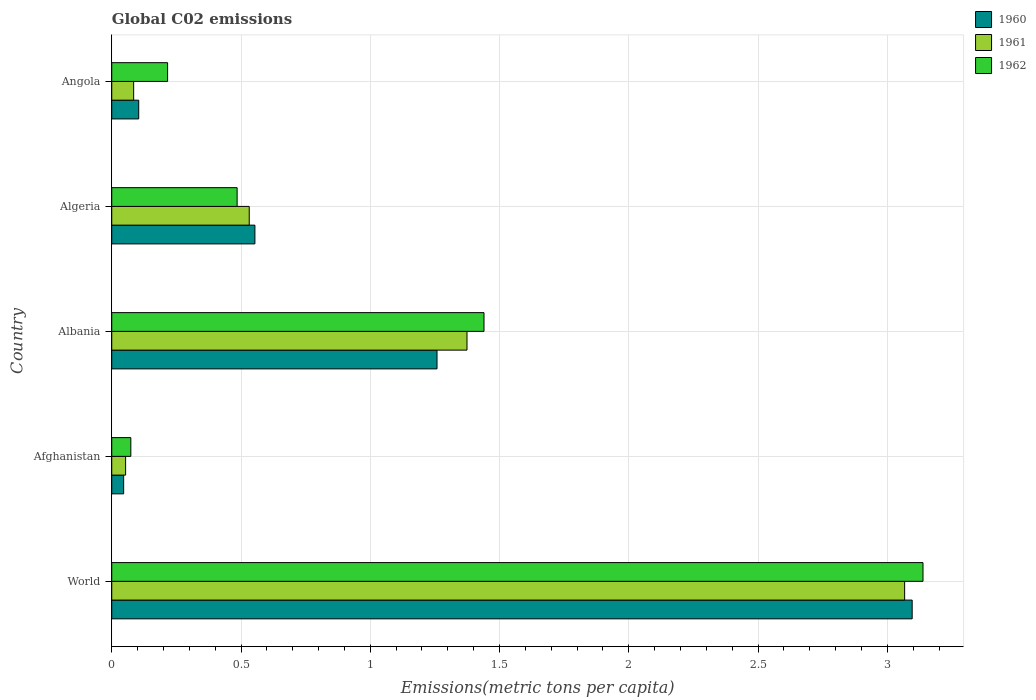How many different coloured bars are there?
Provide a short and direct response. 3. Are the number of bars per tick equal to the number of legend labels?
Provide a succinct answer. Yes. Are the number of bars on each tick of the Y-axis equal?
Keep it short and to the point. Yes. In how many cases, is the number of bars for a given country not equal to the number of legend labels?
Your answer should be compact. 0. What is the amount of CO2 emitted in in 1961 in Algeria?
Your answer should be compact. 0.53. Across all countries, what is the maximum amount of CO2 emitted in in 1961?
Offer a very short reply. 3.07. Across all countries, what is the minimum amount of CO2 emitted in in 1962?
Provide a short and direct response. 0.07. In which country was the amount of CO2 emitted in in 1961 maximum?
Your response must be concise. World. In which country was the amount of CO2 emitted in in 1962 minimum?
Provide a succinct answer. Afghanistan. What is the total amount of CO2 emitted in in 1961 in the graph?
Provide a succinct answer. 5.11. What is the difference between the amount of CO2 emitted in in 1960 in Albania and that in Angola?
Your answer should be compact. 1.15. What is the difference between the amount of CO2 emitted in in 1961 in World and the amount of CO2 emitted in in 1962 in Angola?
Provide a succinct answer. 2.85. What is the average amount of CO2 emitted in in 1961 per country?
Provide a succinct answer. 1.02. What is the difference between the amount of CO2 emitted in in 1960 and amount of CO2 emitted in in 1961 in Angola?
Ensure brevity in your answer.  0.02. In how many countries, is the amount of CO2 emitted in in 1960 greater than 2.9 metric tons per capita?
Offer a very short reply. 1. What is the ratio of the amount of CO2 emitted in in 1962 in Afghanistan to that in Angola?
Your answer should be compact. 0.34. Is the amount of CO2 emitted in in 1961 in Albania less than that in World?
Your answer should be compact. Yes. What is the difference between the highest and the second highest amount of CO2 emitted in in 1960?
Ensure brevity in your answer.  1.84. What is the difference between the highest and the lowest amount of CO2 emitted in in 1962?
Make the answer very short. 3.06. What does the 2nd bar from the top in Albania represents?
Offer a very short reply. 1961. What does the 3rd bar from the bottom in World represents?
Give a very brief answer. 1962. Is it the case that in every country, the sum of the amount of CO2 emitted in in 1962 and amount of CO2 emitted in in 1960 is greater than the amount of CO2 emitted in in 1961?
Keep it short and to the point. Yes. What is the difference between two consecutive major ticks on the X-axis?
Your answer should be very brief. 0.5. Does the graph contain grids?
Ensure brevity in your answer.  Yes. How are the legend labels stacked?
Your response must be concise. Vertical. What is the title of the graph?
Provide a succinct answer. Global C02 emissions. Does "1971" appear as one of the legend labels in the graph?
Give a very brief answer. No. What is the label or title of the X-axis?
Your answer should be compact. Emissions(metric tons per capita). What is the label or title of the Y-axis?
Provide a succinct answer. Country. What is the Emissions(metric tons per capita) in 1960 in World?
Provide a short and direct response. 3.1. What is the Emissions(metric tons per capita) of 1961 in World?
Provide a short and direct response. 3.07. What is the Emissions(metric tons per capita) in 1962 in World?
Your response must be concise. 3.14. What is the Emissions(metric tons per capita) of 1960 in Afghanistan?
Make the answer very short. 0.05. What is the Emissions(metric tons per capita) of 1961 in Afghanistan?
Make the answer very short. 0.05. What is the Emissions(metric tons per capita) in 1962 in Afghanistan?
Your response must be concise. 0.07. What is the Emissions(metric tons per capita) of 1960 in Albania?
Offer a very short reply. 1.26. What is the Emissions(metric tons per capita) of 1961 in Albania?
Your answer should be compact. 1.37. What is the Emissions(metric tons per capita) of 1962 in Albania?
Give a very brief answer. 1.44. What is the Emissions(metric tons per capita) of 1960 in Algeria?
Offer a very short reply. 0.55. What is the Emissions(metric tons per capita) of 1961 in Algeria?
Give a very brief answer. 0.53. What is the Emissions(metric tons per capita) of 1962 in Algeria?
Provide a short and direct response. 0.48. What is the Emissions(metric tons per capita) of 1960 in Angola?
Keep it short and to the point. 0.1. What is the Emissions(metric tons per capita) in 1961 in Angola?
Offer a very short reply. 0.08. What is the Emissions(metric tons per capita) of 1962 in Angola?
Offer a terse response. 0.22. Across all countries, what is the maximum Emissions(metric tons per capita) in 1960?
Ensure brevity in your answer.  3.1. Across all countries, what is the maximum Emissions(metric tons per capita) of 1961?
Your response must be concise. 3.07. Across all countries, what is the maximum Emissions(metric tons per capita) of 1962?
Give a very brief answer. 3.14. Across all countries, what is the minimum Emissions(metric tons per capita) in 1960?
Provide a succinct answer. 0.05. Across all countries, what is the minimum Emissions(metric tons per capita) of 1961?
Give a very brief answer. 0.05. Across all countries, what is the minimum Emissions(metric tons per capita) in 1962?
Make the answer very short. 0.07. What is the total Emissions(metric tons per capita) of 1960 in the graph?
Keep it short and to the point. 5.06. What is the total Emissions(metric tons per capita) of 1961 in the graph?
Your response must be concise. 5.11. What is the total Emissions(metric tons per capita) in 1962 in the graph?
Offer a terse response. 5.35. What is the difference between the Emissions(metric tons per capita) of 1960 in World and that in Afghanistan?
Provide a short and direct response. 3.05. What is the difference between the Emissions(metric tons per capita) of 1961 in World and that in Afghanistan?
Offer a terse response. 3.01. What is the difference between the Emissions(metric tons per capita) in 1962 in World and that in Afghanistan?
Offer a very short reply. 3.06. What is the difference between the Emissions(metric tons per capita) in 1960 in World and that in Albania?
Offer a very short reply. 1.84. What is the difference between the Emissions(metric tons per capita) of 1961 in World and that in Albania?
Offer a terse response. 1.69. What is the difference between the Emissions(metric tons per capita) in 1962 in World and that in Albania?
Your answer should be compact. 1.7. What is the difference between the Emissions(metric tons per capita) of 1960 in World and that in Algeria?
Offer a very short reply. 2.54. What is the difference between the Emissions(metric tons per capita) in 1961 in World and that in Algeria?
Your answer should be compact. 2.54. What is the difference between the Emissions(metric tons per capita) in 1962 in World and that in Algeria?
Offer a very short reply. 2.65. What is the difference between the Emissions(metric tons per capita) in 1960 in World and that in Angola?
Your answer should be very brief. 2.99. What is the difference between the Emissions(metric tons per capita) in 1961 in World and that in Angola?
Offer a very short reply. 2.98. What is the difference between the Emissions(metric tons per capita) in 1962 in World and that in Angola?
Ensure brevity in your answer.  2.92. What is the difference between the Emissions(metric tons per capita) of 1960 in Afghanistan and that in Albania?
Provide a succinct answer. -1.21. What is the difference between the Emissions(metric tons per capita) of 1961 in Afghanistan and that in Albania?
Offer a very short reply. -1.32. What is the difference between the Emissions(metric tons per capita) of 1962 in Afghanistan and that in Albania?
Your answer should be very brief. -1.37. What is the difference between the Emissions(metric tons per capita) of 1960 in Afghanistan and that in Algeria?
Offer a very short reply. -0.51. What is the difference between the Emissions(metric tons per capita) in 1961 in Afghanistan and that in Algeria?
Provide a short and direct response. -0.48. What is the difference between the Emissions(metric tons per capita) of 1962 in Afghanistan and that in Algeria?
Provide a succinct answer. -0.41. What is the difference between the Emissions(metric tons per capita) in 1960 in Afghanistan and that in Angola?
Offer a very short reply. -0.06. What is the difference between the Emissions(metric tons per capita) of 1961 in Afghanistan and that in Angola?
Your answer should be compact. -0.03. What is the difference between the Emissions(metric tons per capita) of 1962 in Afghanistan and that in Angola?
Offer a terse response. -0.14. What is the difference between the Emissions(metric tons per capita) in 1960 in Albania and that in Algeria?
Provide a succinct answer. 0.7. What is the difference between the Emissions(metric tons per capita) of 1961 in Albania and that in Algeria?
Offer a very short reply. 0.84. What is the difference between the Emissions(metric tons per capita) in 1962 in Albania and that in Algeria?
Give a very brief answer. 0.95. What is the difference between the Emissions(metric tons per capita) in 1960 in Albania and that in Angola?
Give a very brief answer. 1.15. What is the difference between the Emissions(metric tons per capita) of 1961 in Albania and that in Angola?
Your answer should be very brief. 1.29. What is the difference between the Emissions(metric tons per capita) of 1962 in Albania and that in Angola?
Provide a succinct answer. 1.22. What is the difference between the Emissions(metric tons per capita) in 1960 in Algeria and that in Angola?
Your answer should be compact. 0.45. What is the difference between the Emissions(metric tons per capita) of 1961 in Algeria and that in Angola?
Your answer should be compact. 0.45. What is the difference between the Emissions(metric tons per capita) of 1962 in Algeria and that in Angola?
Keep it short and to the point. 0.27. What is the difference between the Emissions(metric tons per capita) of 1960 in World and the Emissions(metric tons per capita) of 1961 in Afghanistan?
Your answer should be very brief. 3.04. What is the difference between the Emissions(metric tons per capita) in 1960 in World and the Emissions(metric tons per capita) in 1962 in Afghanistan?
Provide a short and direct response. 3.02. What is the difference between the Emissions(metric tons per capita) in 1961 in World and the Emissions(metric tons per capita) in 1962 in Afghanistan?
Your answer should be very brief. 2.99. What is the difference between the Emissions(metric tons per capita) of 1960 in World and the Emissions(metric tons per capita) of 1961 in Albania?
Your answer should be very brief. 1.72. What is the difference between the Emissions(metric tons per capita) in 1960 in World and the Emissions(metric tons per capita) in 1962 in Albania?
Give a very brief answer. 1.66. What is the difference between the Emissions(metric tons per capita) of 1961 in World and the Emissions(metric tons per capita) of 1962 in Albania?
Keep it short and to the point. 1.63. What is the difference between the Emissions(metric tons per capita) of 1960 in World and the Emissions(metric tons per capita) of 1961 in Algeria?
Your answer should be very brief. 2.56. What is the difference between the Emissions(metric tons per capita) of 1960 in World and the Emissions(metric tons per capita) of 1962 in Algeria?
Your answer should be very brief. 2.61. What is the difference between the Emissions(metric tons per capita) of 1961 in World and the Emissions(metric tons per capita) of 1962 in Algeria?
Offer a very short reply. 2.58. What is the difference between the Emissions(metric tons per capita) in 1960 in World and the Emissions(metric tons per capita) in 1961 in Angola?
Your answer should be very brief. 3.01. What is the difference between the Emissions(metric tons per capita) of 1960 in World and the Emissions(metric tons per capita) of 1962 in Angola?
Ensure brevity in your answer.  2.88. What is the difference between the Emissions(metric tons per capita) of 1961 in World and the Emissions(metric tons per capita) of 1962 in Angola?
Offer a terse response. 2.85. What is the difference between the Emissions(metric tons per capita) of 1960 in Afghanistan and the Emissions(metric tons per capita) of 1961 in Albania?
Offer a terse response. -1.33. What is the difference between the Emissions(metric tons per capita) in 1960 in Afghanistan and the Emissions(metric tons per capita) in 1962 in Albania?
Your answer should be very brief. -1.39. What is the difference between the Emissions(metric tons per capita) in 1961 in Afghanistan and the Emissions(metric tons per capita) in 1962 in Albania?
Your answer should be very brief. -1.39. What is the difference between the Emissions(metric tons per capita) of 1960 in Afghanistan and the Emissions(metric tons per capita) of 1961 in Algeria?
Ensure brevity in your answer.  -0.49. What is the difference between the Emissions(metric tons per capita) of 1960 in Afghanistan and the Emissions(metric tons per capita) of 1962 in Algeria?
Make the answer very short. -0.44. What is the difference between the Emissions(metric tons per capita) of 1961 in Afghanistan and the Emissions(metric tons per capita) of 1962 in Algeria?
Make the answer very short. -0.43. What is the difference between the Emissions(metric tons per capita) in 1960 in Afghanistan and the Emissions(metric tons per capita) in 1961 in Angola?
Your answer should be compact. -0.04. What is the difference between the Emissions(metric tons per capita) in 1960 in Afghanistan and the Emissions(metric tons per capita) in 1962 in Angola?
Make the answer very short. -0.17. What is the difference between the Emissions(metric tons per capita) in 1961 in Afghanistan and the Emissions(metric tons per capita) in 1962 in Angola?
Keep it short and to the point. -0.16. What is the difference between the Emissions(metric tons per capita) in 1960 in Albania and the Emissions(metric tons per capita) in 1961 in Algeria?
Provide a succinct answer. 0.73. What is the difference between the Emissions(metric tons per capita) of 1960 in Albania and the Emissions(metric tons per capita) of 1962 in Algeria?
Make the answer very short. 0.77. What is the difference between the Emissions(metric tons per capita) of 1961 in Albania and the Emissions(metric tons per capita) of 1962 in Algeria?
Offer a very short reply. 0.89. What is the difference between the Emissions(metric tons per capita) of 1960 in Albania and the Emissions(metric tons per capita) of 1961 in Angola?
Provide a succinct answer. 1.17. What is the difference between the Emissions(metric tons per capita) of 1960 in Albania and the Emissions(metric tons per capita) of 1962 in Angola?
Your answer should be very brief. 1.04. What is the difference between the Emissions(metric tons per capita) in 1961 in Albania and the Emissions(metric tons per capita) in 1962 in Angola?
Keep it short and to the point. 1.16. What is the difference between the Emissions(metric tons per capita) of 1960 in Algeria and the Emissions(metric tons per capita) of 1961 in Angola?
Provide a short and direct response. 0.47. What is the difference between the Emissions(metric tons per capita) in 1960 in Algeria and the Emissions(metric tons per capita) in 1962 in Angola?
Your answer should be very brief. 0.34. What is the difference between the Emissions(metric tons per capita) of 1961 in Algeria and the Emissions(metric tons per capita) of 1962 in Angola?
Offer a terse response. 0.32. What is the average Emissions(metric tons per capita) in 1960 per country?
Offer a terse response. 1.01. What is the average Emissions(metric tons per capita) in 1961 per country?
Make the answer very short. 1.02. What is the average Emissions(metric tons per capita) of 1962 per country?
Give a very brief answer. 1.07. What is the difference between the Emissions(metric tons per capita) of 1960 and Emissions(metric tons per capita) of 1961 in World?
Ensure brevity in your answer.  0.03. What is the difference between the Emissions(metric tons per capita) in 1960 and Emissions(metric tons per capita) in 1962 in World?
Your answer should be very brief. -0.04. What is the difference between the Emissions(metric tons per capita) of 1961 and Emissions(metric tons per capita) of 1962 in World?
Ensure brevity in your answer.  -0.07. What is the difference between the Emissions(metric tons per capita) of 1960 and Emissions(metric tons per capita) of 1961 in Afghanistan?
Provide a succinct answer. -0.01. What is the difference between the Emissions(metric tons per capita) of 1960 and Emissions(metric tons per capita) of 1962 in Afghanistan?
Offer a very short reply. -0.03. What is the difference between the Emissions(metric tons per capita) of 1961 and Emissions(metric tons per capita) of 1962 in Afghanistan?
Provide a succinct answer. -0.02. What is the difference between the Emissions(metric tons per capita) in 1960 and Emissions(metric tons per capita) in 1961 in Albania?
Provide a short and direct response. -0.12. What is the difference between the Emissions(metric tons per capita) of 1960 and Emissions(metric tons per capita) of 1962 in Albania?
Your response must be concise. -0.18. What is the difference between the Emissions(metric tons per capita) in 1961 and Emissions(metric tons per capita) in 1962 in Albania?
Offer a very short reply. -0.07. What is the difference between the Emissions(metric tons per capita) in 1960 and Emissions(metric tons per capita) in 1961 in Algeria?
Offer a terse response. 0.02. What is the difference between the Emissions(metric tons per capita) in 1960 and Emissions(metric tons per capita) in 1962 in Algeria?
Your response must be concise. 0.07. What is the difference between the Emissions(metric tons per capita) in 1961 and Emissions(metric tons per capita) in 1962 in Algeria?
Your response must be concise. 0.05. What is the difference between the Emissions(metric tons per capita) of 1960 and Emissions(metric tons per capita) of 1961 in Angola?
Provide a succinct answer. 0.02. What is the difference between the Emissions(metric tons per capita) in 1960 and Emissions(metric tons per capita) in 1962 in Angola?
Provide a succinct answer. -0.11. What is the difference between the Emissions(metric tons per capita) in 1961 and Emissions(metric tons per capita) in 1962 in Angola?
Ensure brevity in your answer.  -0.13. What is the ratio of the Emissions(metric tons per capita) in 1960 in World to that in Afghanistan?
Your response must be concise. 67.21. What is the ratio of the Emissions(metric tons per capita) in 1961 in World to that in Afghanistan?
Your response must be concise. 57.21. What is the ratio of the Emissions(metric tons per capita) of 1962 in World to that in Afghanistan?
Provide a short and direct response. 42.53. What is the ratio of the Emissions(metric tons per capita) of 1960 in World to that in Albania?
Provide a succinct answer. 2.46. What is the ratio of the Emissions(metric tons per capita) in 1961 in World to that in Albania?
Your answer should be very brief. 2.23. What is the ratio of the Emissions(metric tons per capita) in 1962 in World to that in Albania?
Give a very brief answer. 2.18. What is the ratio of the Emissions(metric tons per capita) in 1960 in World to that in Algeria?
Give a very brief answer. 5.59. What is the ratio of the Emissions(metric tons per capita) in 1961 in World to that in Algeria?
Your answer should be compact. 5.77. What is the ratio of the Emissions(metric tons per capita) of 1962 in World to that in Algeria?
Make the answer very short. 6.47. What is the ratio of the Emissions(metric tons per capita) in 1960 in World to that in Angola?
Give a very brief answer. 29.67. What is the ratio of the Emissions(metric tons per capita) of 1961 in World to that in Angola?
Make the answer very short. 36.2. What is the ratio of the Emissions(metric tons per capita) of 1962 in World to that in Angola?
Provide a short and direct response. 14.53. What is the ratio of the Emissions(metric tons per capita) of 1960 in Afghanistan to that in Albania?
Offer a terse response. 0.04. What is the ratio of the Emissions(metric tons per capita) of 1961 in Afghanistan to that in Albania?
Keep it short and to the point. 0.04. What is the ratio of the Emissions(metric tons per capita) in 1962 in Afghanistan to that in Albania?
Keep it short and to the point. 0.05. What is the ratio of the Emissions(metric tons per capita) of 1960 in Afghanistan to that in Algeria?
Make the answer very short. 0.08. What is the ratio of the Emissions(metric tons per capita) in 1961 in Afghanistan to that in Algeria?
Provide a short and direct response. 0.1. What is the ratio of the Emissions(metric tons per capita) in 1962 in Afghanistan to that in Algeria?
Make the answer very short. 0.15. What is the ratio of the Emissions(metric tons per capita) of 1960 in Afghanistan to that in Angola?
Your answer should be compact. 0.44. What is the ratio of the Emissions(metric tons per capita) of 1961 in Afghanistan to that in Angola?
Your answer should be very brief. 0.63. What is the ratio of the Emissions(metric tons per capita) in 1962 in Afghanistan to that in Angola?
Offer a terse response. 0.34. What is the ratio of the Emissions(metric tons per capita) of 1960 in Albania to that in Algeria?
Offer a terse response. 2.27. What is the ratio of the Emissions(metric tons per capita) in 1961 in Albania to that in Algeria?
Provide a short and direct response. 2.58. What is the ratio of the Emissions(metric tons per capita) of 1962 in Albania to that in Algeria?
Give a very brief answer. 2.97. What is the ratio of the Emissions(metric tons per capita) in 1960 in Albania to that in Angola?
Provide a succinct answer. 12.06. What is the ratio of the Emissions(metric tons per capita) in 1961 in Albania to that in Angola?
Your answer should be compact. 16.22. What is the ratio of the Emissions(metric tons per capita) in 1962 in Albania to that in Angola?
Your answer should be very brief. 6.67. What is the ratio of the Emissions(metric tons per capita) in 1960 in Algeria to that in Angola?
Provide a succinct answer. 5.31. What is the ratio of the Emissions(metric tons per capita) in 1961 in Algeria to that in Angola?
Provide a short and direct response. 6.28. What is the ratio of the Emissions(metric tons per capita) of 1962 in Algeria to that in Angola?
Your response must be concise. 2.24. What is the difference between the highest and the second highest Emissions(metric tons per capita) in 1960?
Make the answer very short. 1.84. What is the difference between the highest and the second highest Emissions(metric tons per capita) in 1961?
Your response must be concise. 1.69. What is the difference between the highest and the second highest Emissions(metric tons per capita) of 1962?
Your answer should be compact. 1.7. What is the difference between the highest and the lowest Emissions(metric tons per capita) of 1960?
Ensure brevity in your answer.  3.05. What is the difference between the highest and the lowest Emissions(metric tons per capita) in 1961?
Ensure brevity in your answer.  3.01. What is the difference between the highest and the lowest Emissions(metric tons per capita) of 1962?
Keep it short and to the point. 3.06. 